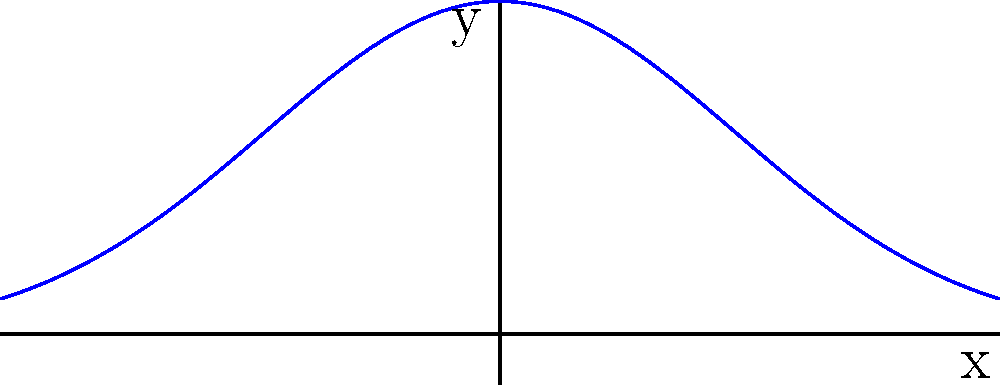The image above represents the directional spread of sound from a choir using a vector field. The blue curves show the intensity of sound propagation, and the red arrows indicate the direction of sound. If the choir is positioned at the origin (0,0), what is the divergence of the sound field at this point, assuming the vector field is given by $\mathbf{F}(x,y) = (x, 2y)$? To find the divergence of the vector field at the origin, we need to follow these steps:

1) The divergence of a vector field $\mathbf{F}(x,y) = (P(x,y), Q(x,y))$ in 2D is given by:

   $\text{div}\mathbf{F} = \nabla \cdot \mathbf{F} = \frac{\partial P}{\partial x} + \frac{\partial Q}{\partial y}$

2) In this case, $\mathbf{F}(x,y) = (x, 2y)$, so $P(x,y) = x$ and $Q(x,y) = 2y$

3) Calculate $\frac{\partial P}{\partial x}$:
   $\frac{\partial P}{\partial x} = \frac{\partial}{\partial x}(x) = 1$

4) Calculate $\frac{\partial Q}{\partial y}$:
   $\frac{\partial Q}{\partial y} = \frac{\partial}{\partial y}(2y) = 2$

5) Sum the partial derivatives:
   $\text{div}\mathbf{F} = \frac{\partial P}{\partial x} + \frac{\partial Q}{\partial y} = 1 + 2 = 3$

6) This result is constant and doesn't depend on x or y, so it's the same at all points, including the origin (0,0).

Therefore, the divergence of the sound field at the point where the choir is positioned (the origin) is 3.
Answer: 3 